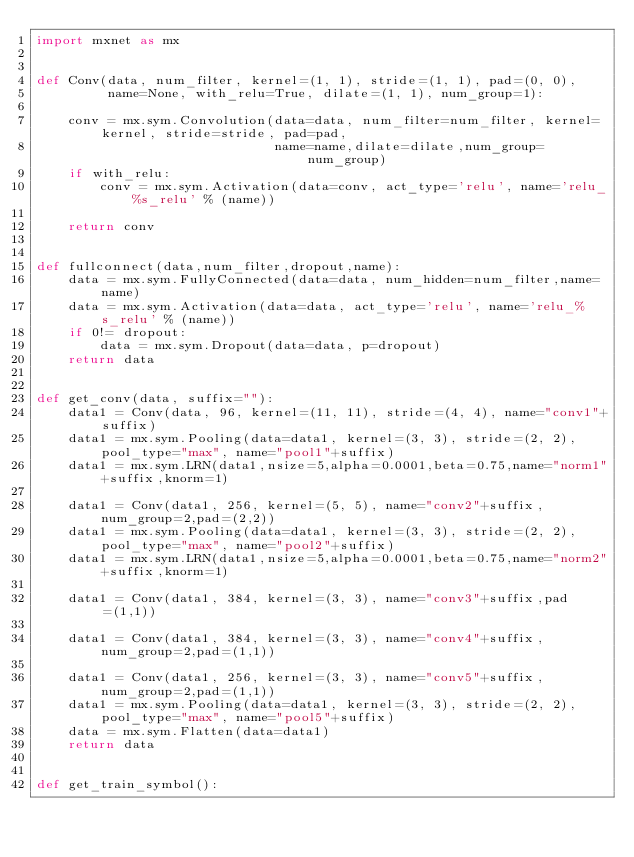Convert code to text. <code><loc_0><loc_0><loc_500><loc_500><_Python_>import mxnet as mx


def Conv(data, num_filter, kernel=(1, 1), stride=(1, 1), pad=(0, 0),
         name=None, with_relu=True, dilate=(1, 1), num_group=1):

    conv = mx.sym.Convolution(data=data, num_filter=num_filter, kernel=kernel, stride=stride, pad=pad,
                              name=name,dilate=dilate,num_group=num_group)
    if with_relu:
        conv = mx.sym.Activation(data=conv, act_type='relu', name='relu_%s_relu' % (name))

    return conv


def fullconnect(data,num_filter,dropout,name):
    data = mx.sym.FullyConnected(data=data, num_hidden=num_filter,name=name)
    data = mx.sym.Activation(data=data, act_type='relu', name='relu_%s_relu' % (name))
    if 0!= dropout:
        data = mx.sym.Dropout(data=data, p=dropout)
    return data


def get_conv(data, suffix=""):
    data1 = Conv(data, 96, kernel=(11, 11), stride=(4, 4), name="conv1"+suffix)
    data1 = mx.sym.Pooling(data=data1, kernel=(3, 3), stride=(2, 2), pool_type="max", name="pool1"+suffix)
    data1 = mx.sym.LRN(data1,nsize=5,alpha=0.0001,beta=0.75,name="norm1"+suffix,knorm=1)

    data1 = Conv(data1, 256, kernel=(5, 5), name="conv2"+suffix,num_group=2,pad=(2,2))
    data1 = mx.sym.Pooling(data=data1, kernel=(3, 3), stride=(2, 2), pool_type="max", name="pool2"+suffix)
    data1 = mx.sym.LRN(data1,nsize=5,alpha=0.0001,beta=0.75,name="norm2"+suffix,knorm=1)

    data1 = Conv(data1, 384, kernel=(3, 3), name="conv3"+suffix,pad=(1,1))

    data1 = Conv(data1, 384, kernel=(3, 3), name="conv4"+suffix,num_group=2,pad=(1,1))

    data1 = Conv(data1, 256, kernel=(3, 3), name="conv5"+suffix,num_group=2,pad=(1,1))
    data1 = mx.sym.Pooling(data=data1, kernel=(3, 3), stride=(2, 2), pool_type="max", name="pool5"+suffix)
    data = mx.sym.Flatten(data=data1)
    return data


def get_train_symbol():</code> 